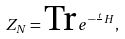Convert formula to latex. <formula><loc_0><loc_0><loc_500><loc_500>Z _ { N } = \text {Tr} \, e ^ { - \frac { t } { } H } ,</formula> 